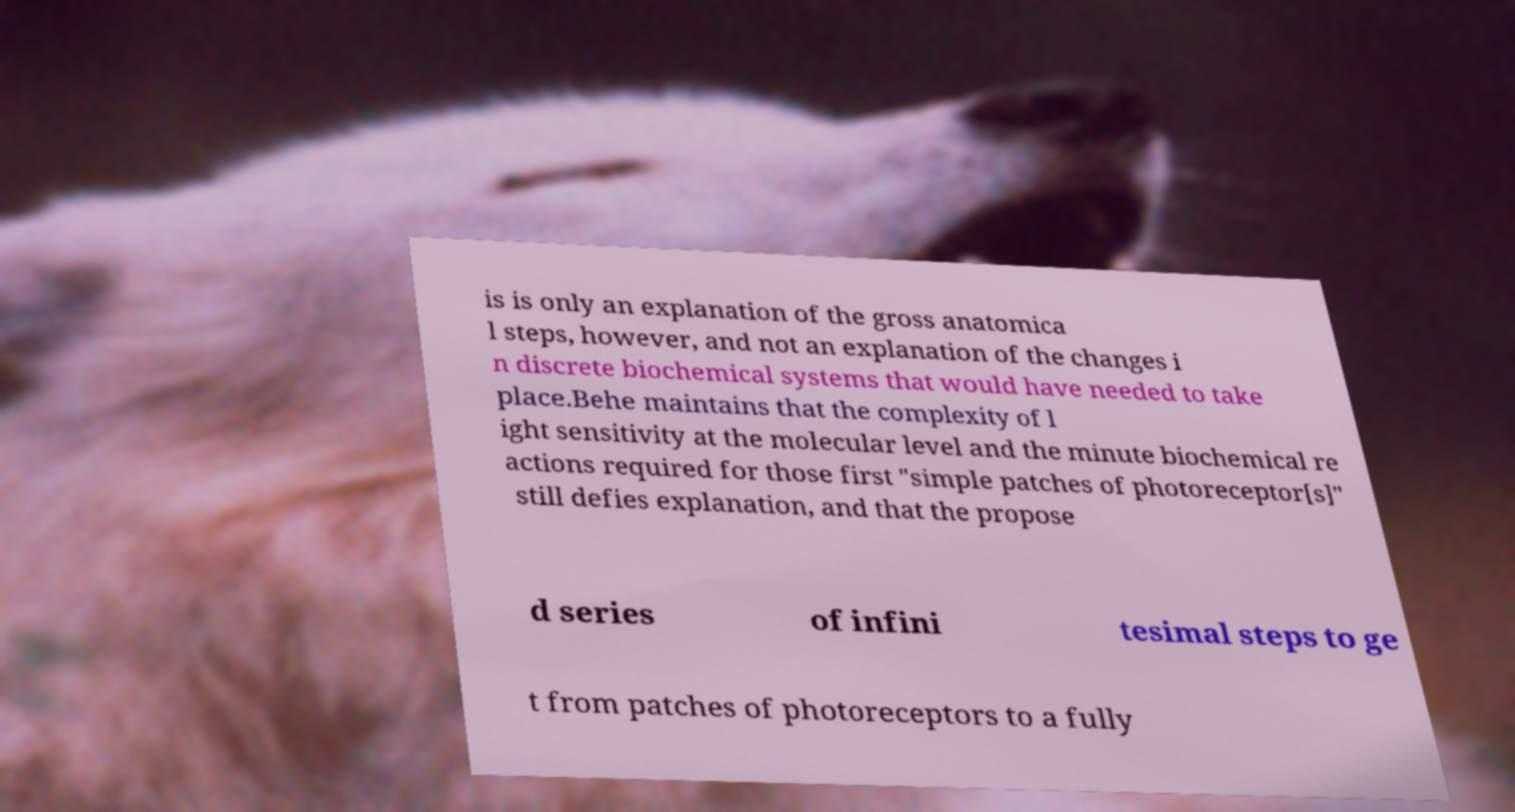Can you accurately transcribe the text from the provided image for me? is is only an explanation of the gross anatomica l steps, however, and not an explanation of the changes i n discrete biochemical systems that would have needed to take place.Behe maintains that the complexity of l ight sensitivity at the molecular level and the minute biochemical re actions required for those first "simple patches of photoreceptor[s]" still defies explanation, and that the propose d series of infini tesimal steps to ge t from patches of photoreceptors to a fully 